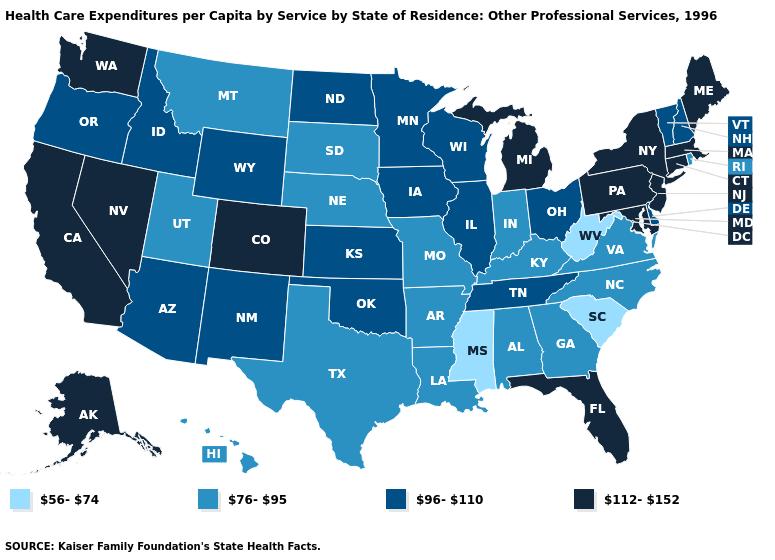What is the value of Utah?
Concise answer only. 76-95. Does the map have missing data?
Write a very short answer. No. What is the value of Connecticut?
Write a very short answer. 112-152. Name the states that have a value in the range 112-152?
Give a very brief answer. Alaska, California, Colorado, Connecticut, Florida, Maine, Maryland, Massachusetts, Michigan, Nevada, New Jersey, New York, Pennsylvania, Washington. Among the states that border Virginia , does West Virginia have the lowest value?
Quick response, please. Yes. Name the states that have a value in the range 76-95?
Concise answer only. Alabama, Arkansas, Georgia, Hawaii, Indiana, Kentucky, Louisiana, Missouri, Montana, Nebraska, North Carolina, Rhode Island, South Dakota, Texas, Utah, Virginia. What is the value of Kansas?
Quick response, please. 96-110. Name the states that have a value in the range 112-152?
Give a very brief answer. Alaska, California, Colorado, Connecticut, Florida, Maine, Maryland, Massachusetts, Michigan, Nevada, New Jersey, New York, Pennsylvania, Washington. Which states have the lowest value in the USA?
Answer briefly. Mississippi, South Carolina, West Virginia. What is the lowest value in the West?
Quick response, please. 76-95. What is the lowest value in states that border Tennessee?
Give a very brief answer. 56-74. What is the lowest value in the MidWest?
Answer briefly. 76-95. Does the map have missing data?
Quick response, please. No. Which states have the highest value in the USA?
Quick response, please. Alaska, California, Colorado, Connecticut, Florida, Maine, Maryland, Massachusetts, Michigan, Nevada, New Jersey, New York, Pennsylvania, Washington. 